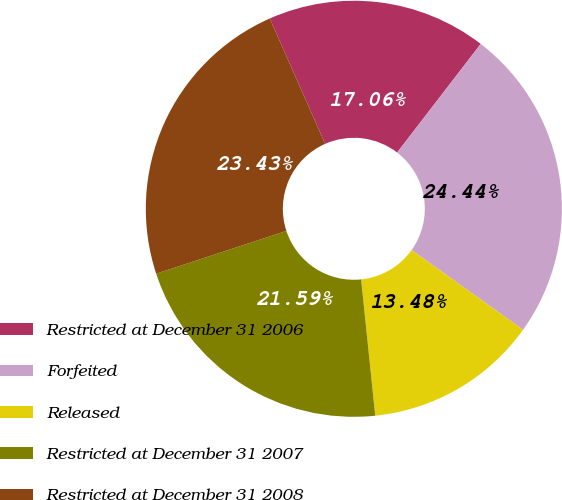Convert chart to OTSL. <chart><loc_0><loc_0><loc_500><loc_500><pie_chart><fcel>Restricted at December 31 2006<fcel>Forfeited<fcel>Released<fcel>Restricted at December 31 2007<fcel>Restricted at December 31 2008<nl><fcel>17.06%<fcel>24.44%<fcel>13.48%<fcel>21.59%<fcel>23.43%<nl></chart> 